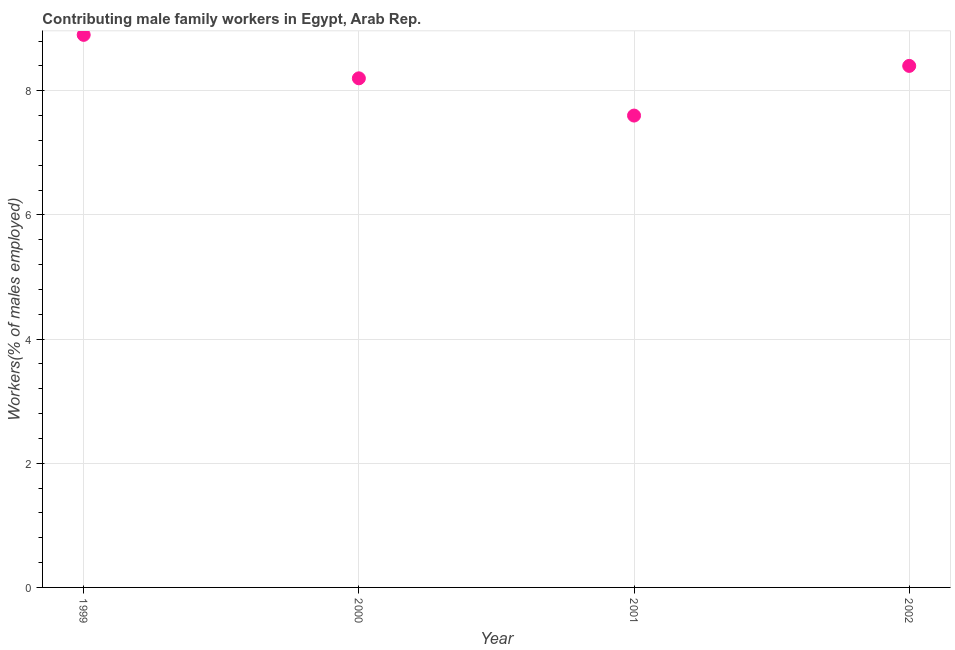What is the contributing male family workers in 2002?
Make the answer very short. 8.4. Across all years, what is the maximum contributing male family workers?
Provide a short and direct response. 8.9. Across all years, what is the minimum contributing male family workers?
Your response must be concise. 7.6. What is the sum of the contributing male family workers?
Provide a short and direct response. 33.1. What is the difference between the contributing male family workers in 2001 and 2002?
Ensure brevity in your answer.  -0.8. What is the average contributing male family workers per year?
Your answer should be compact. 8.27. What is the median contributing male family workers?
Offer a terse response. 8.3. What is the ratio of the contributing male family workers in 1999 to that in 2001?
Give a very brief answer. 1.17. Is the contributing male family workers in 2000 less than that in 2001?
Ensure brevity in your answer.  No. What is the difference between the highest and the second highest contributing male family workers?
Ensure brevity in your answer.  0.5. What is the difference between the highest and the lowest contributing male family workers?
Make the answer very short. 1.3. Does the contributing male family workers monotonically increase over the years?
Your answer should be very brief. No. How many years are there in the graph?
Your answer should be compact. 4. Are the values on the major ticks of Y-axis written in scientific E-notation?
Provide a succinct answer. No. Does the graph contain any zero values?
Make the answer very short. No. Does the graph contain grids?
Your answer should be compact. Yes. What is the title of the graph?
Offer a very short reply. Contributing male family workers in Egypt, Arab Rep. What is the label or title of the Y-axis?
Ensure brevity in your answer.  Workers(% of males employed). What is the Workers(% of males employed) in 1999?
Keep it short and to the point. 8.9. What is the Workers(% of males employed) in 2000?
Keep it short and to the point. 8.2. What is the Workers(% of males employed) in 2001?
Keep it short and to the point. 7.6. What is the Workers(% of males employed) in 2002?
Offer a very short reply. 8.4. What is the difference between the Workers(% of males employed) in 1999 and 2000?
Give a very brief answer. 0.7. What is the difference between the Workers(% of males employed) in 1999 and 2002?
Provide a short and direct response. 0.5. What is the difference between the Workers(% of males employed) in 2000 and 2001?
Ensure brevity in your answer.  0.6. What is the ratio of the Workers(% of males employed) in 1999 to that in 2000?
Give a very brief answer. 1.08. What is the ratio of the Workers(% of males employed) in 1999 to that in 2001?
Offer a terse response. 1.17. What is the ratio of the Workers(% of males employed) in 1999 to that in 2002?
Your answer should be very brief. 1.06. What is the ratio of the Workers(% of males employed) in 2000 to that in 2001?
Your answer should be very brief. 1.08. What is the ratio of the Workers(% of males employed) in 2000 to that in 2002?
Keep it short and to the point. 0.98. What is the ratio of the Workers(% of males employed) in 2001 to that in 2002?
Your answer should be very brief. 0.91. 